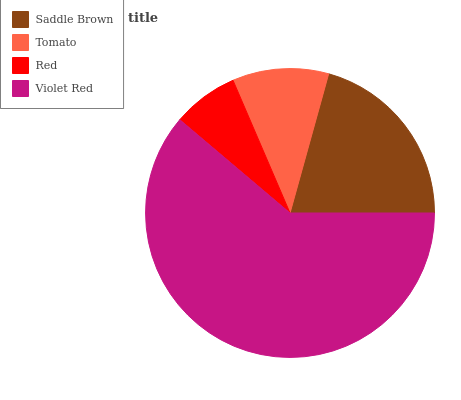Is Red the minimum?
Answer yes or no. Yes. Is Violet Red the maximum?
Answer yes or no. Yes. Is Tomato the minimum?
Answer yes or no. No. Is Tomato the maximum?
Answer yes or no. No. Is Saddle Brown greater than Tomato?
Answer yes or no. Yes. Is Tomato less than Saddle Brown?
Answer yes or no. Yes. Is Tomato greater than Saddle Brown?
Answer yes or no. No. Is Saddle Brown less than Tomato?
Answer yes or no. No. Is Saddle Brown the high median?
Answer yes or no. Yes. Is Tomato the low median?
Answer yes or no. Yes. Is Tomato the high median?
Answer yes or no. No. Is Red the low median?
Answer yes or no. No. 